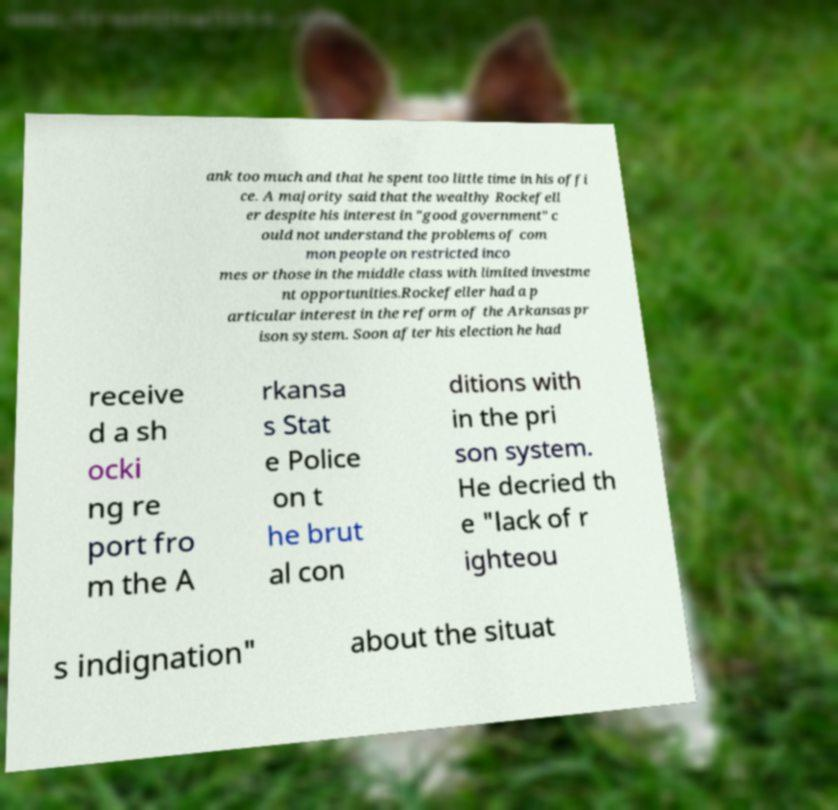There's text embedded in this image that I need extracted. Can you transcribe it verbatim? ank too much and that he spent too little time in his offi ce. A majority said that the wealthy Rockefell er despite his interest in "good government" c ould not understand the problems of com mon people on restricted inco mes or those in the middle class with limited investme nt opportunities.Rockefeller had a p articular interest in the reform of the Arkansas pr ison system. Soon after his election he had receive d a sh ocki ng re port fro m the A rkansa s Stat e Police on t he brut al con ditions with in the pri son system. He decried th e "lack of r ighteou s indignation" about the situat 